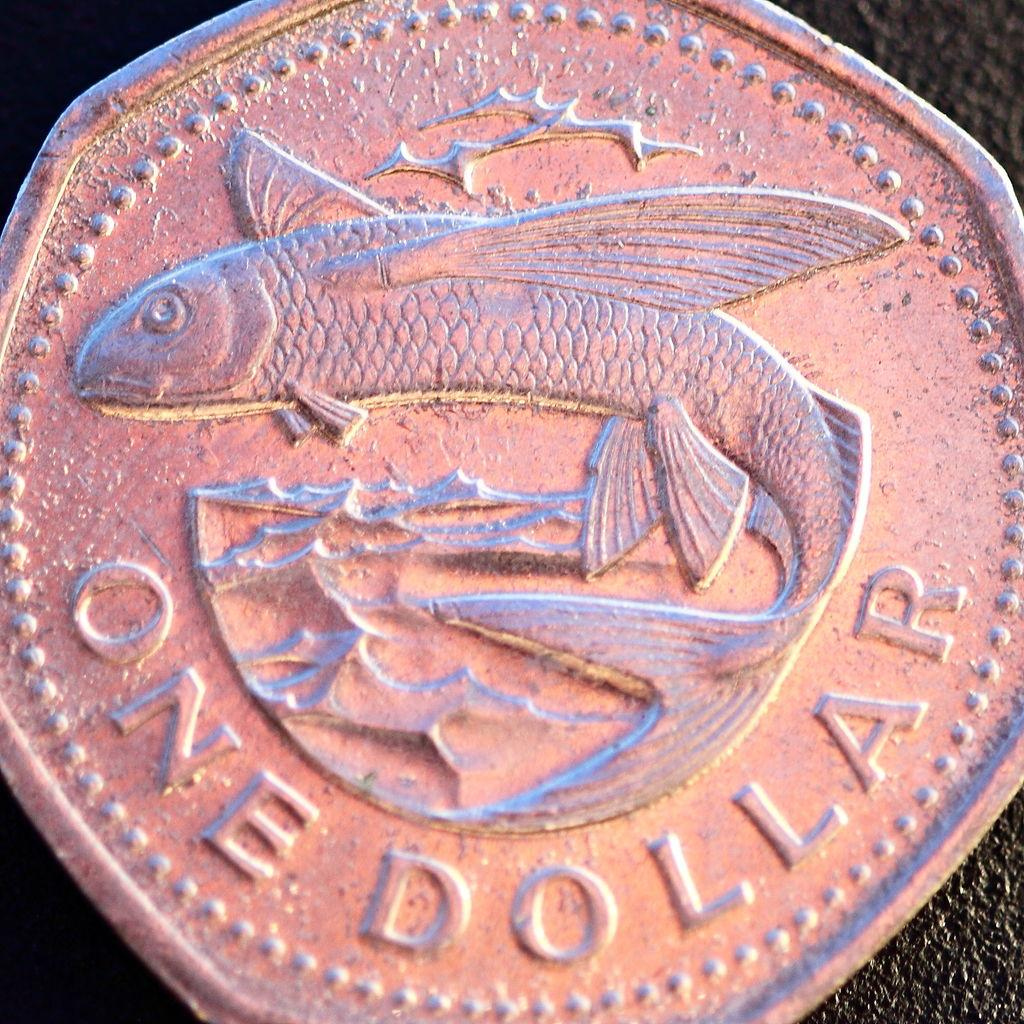Provide a one-sentence caption for the provided image. A one dollar coin with a flying fish on it. 